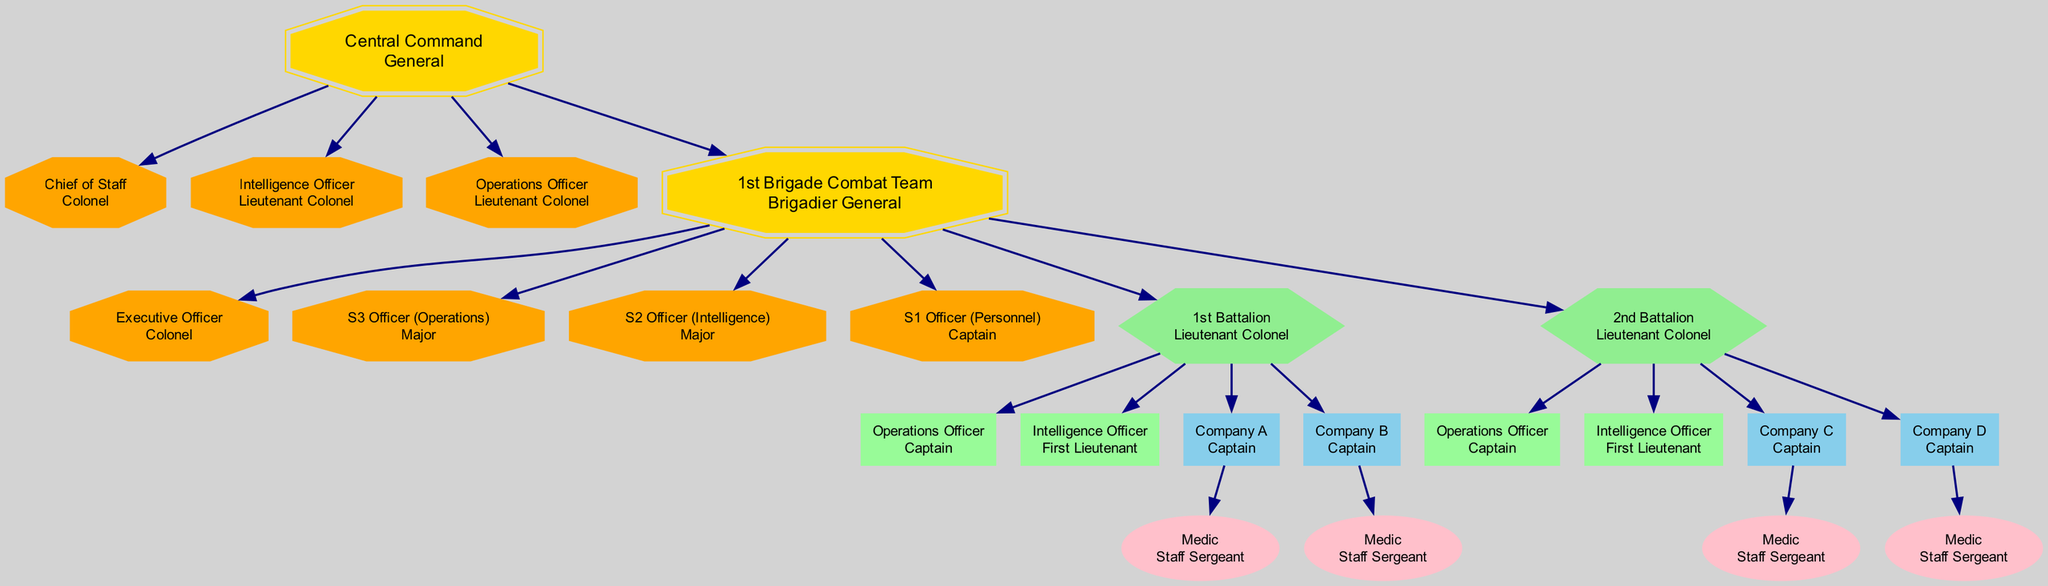What is the name of the headquarters? The data specifies that the headquarters is called "Central Command." This information is located at the top of the hierarchy.
Answer: Central Command How many staff positions are there at the headquarters? The headquarters has three staff positions listed: Chief of Staff, Intelligence Officer, and Operations Officer. By counting these, we find there are three.
Answer: 3 Who commands the 1st Battalion? The commander of the 1st Battalion is a Lieutenant Colonel as indicated in the hierarchy section for the battalion.
Answer: Lieutenant Colonel What is the rank of the S3 Officer (Operations)? The data states that the S3 Officer (Operations) is a Major, which can be found in the staff positions listed under the brigade.
Answer: Major Which company has a medic designated as Staff Sergeant? Both Company A and Company B have a medic designated as Staff Sergeant, as indicated in their respective entries under the units of the 1st Battalion.
Answer: Company A and Company B How many battalions are under the brigade? The brigade has two battalions listed: the 1st Battalion and the 2nd Battalion. By simply counting these, we arrive at the answer.
Answer: 2 What is the relationship between the S2 Officer and the brigade commander? The S2 Officer (Intelligence) is a staff position under the brigade, which means they report directly to the brigade commander, who is a Brigadier General. Thus, the relationship is one of direct report.
Answer: Reports directly to Which officer ranks below the Chief of Staff? The Intelligence Officer and Operations Officer are both of the rank Lieutenant Colonel, which is below the rank of Colonel held by the Chief of Staff.
Answer: Intelligence Officer and Operations Officer What shapes represent the battalions in the diagram? The battalions are represented by hexagons, as specified in the diagram generation code, which designates this shape for battalion-level nodes.
Answer: Hexagon 